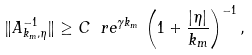Convert formula to latex. <formula><loc_0><loc_0><loc_500><loc_500>\| A _ { k _ { m } , \eta } ^ { - 1 } \| \geq C \ r e ^ { \gamma k _ { m } } \, \left ( 1 + \frac { | \eta | } { k _ { m } } \right ) ^ { - 1 } ,</formula> 